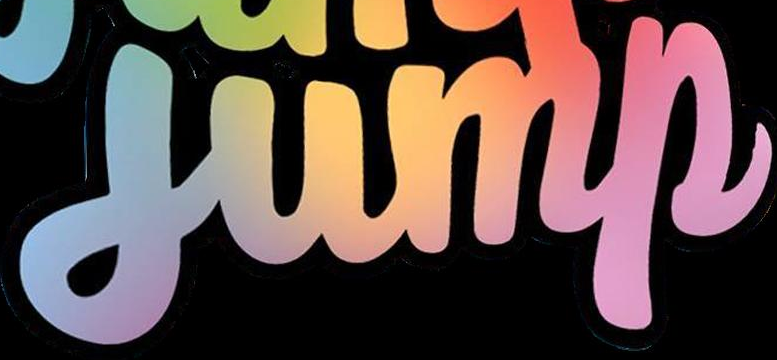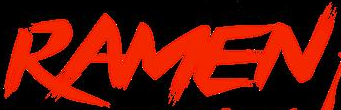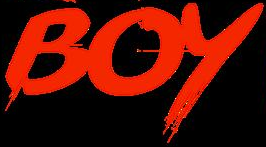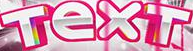Read the text content from these images in order, separated by a semicolon. jump; RAMEN; BOY; TexT 